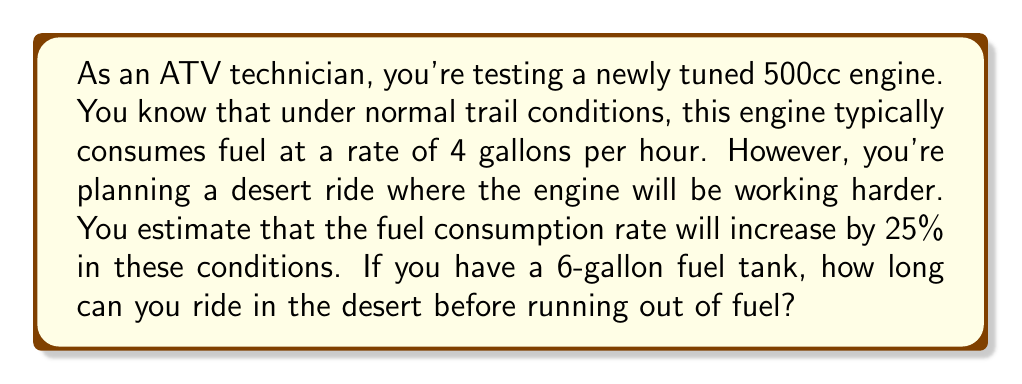Give your solution to this math problem. Let's approach this problem step-by-step:

1) First, we need to calculate the new fuel consumption rate for desert conditions.
   Normal rate: 4 gallons/hour
   Increase: 25% = 0.25
   
   $$\text{Desert rate} = 4 + (4 \times 0.25) = 4 + 1 = 5 \text{ gallons/hour}$$

2) Now we have a rate problem:
   Rate: 5 gallons/hour
   Total amount: 6 gallons (tank capacity)
   Time: unknown

3) We can use the formula:
   $$\text{Time} = \frac{\text{Total amount}}{\text{Rate}}$$

4) Plugging in our values:
   $$\text{Time} = \frac{6 \text{ gallons}}{5 \text{ gallons/hour}}$$

5) Simplifying:
   $$\text{Time} = \frac{6}{5} \text{ hours} = 1.2 \text{ hours}$$

6) Converting to hours and minutes:
   0.2 hours = 0.2 × 60 minutes = 12 minutes

Therefore, you can ride for 1 hour and 12 minutes before running out of fuel.
Answer: 1 hour and 12 minutes 